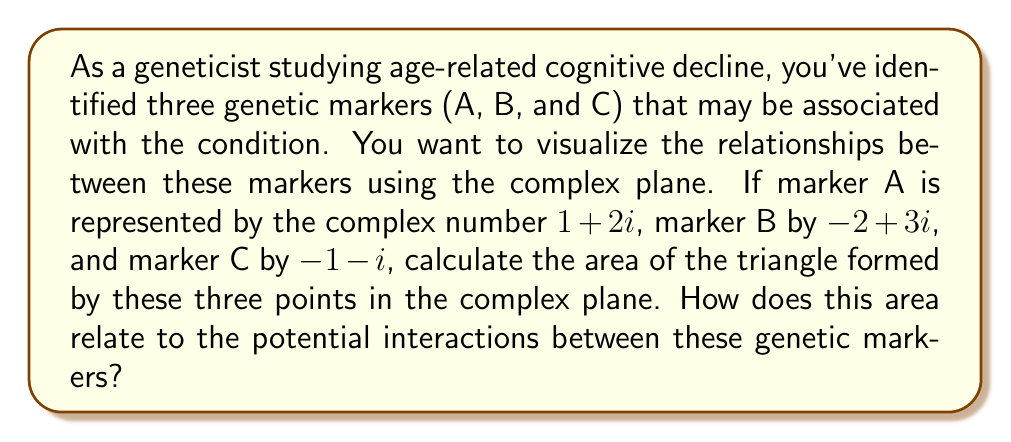Show me your answer to this math problem. To solve this problem, we'll follow these steps:

1) First, let's plot the points on the complex plane:
   A: $1+2i$
   B: $-2+3i$
   C: $-1-i$

2) To find the area of a triangle in the complex plane, we can use the formula:

   $$\text{Area} = \frac{1}{2}|\text{Im}(z_1\bar{z_2} + z_2\bar{z_3} + z_3\bar{z_1})|$$

   where $z_1$, $z_2$, and $z_3$ are the complex numbers representing the vertices, and $\bar{z}$ denotes the complex conjugate.

3) Let's calculate each term:

   $z_1\bar{z_2} = (1+2i)(-2-3i) = -2-3i-4i-6i^2 = -2-7i+6 = 4-7i$
   
   $z_2\bar{z_3} = (-2+3i)(-1+i) = 2-2i-3i-3i^2 = 2-5i+3 = 5-5i$
   
   $z_3\bar{z_1} = (-1-i)(1-2i) = -1+2i+i-2i^2 = -1+3i+2 = 1+3i$

4) Sum these terms:

   $(4-7i) + (5-5i) + (1+3i) = 10-9i$

5) Take the imaginary part:

   $\text{Im}(10-9i) = -9$

6) Calculate the absolute value and divide by 2:

   $\text{Area} = \frac{1}{2}|-9| = \frac{9}{2} = 4.5$

The area of the triangle is 4.5 square units in the complex plane.

In the context of genetic markers, this area could represent the magnitude of potential interactions or relationships between the three markers. A larger area might suggest stronger or more complex interactions, while a smaller area might indicate weaker or simpler relationships. However, the interpretation would depend on how the complex numbers were initially assigned to represent the genetic markers and what aspects of the markers they represent (e.g., expression levels, mutation frequencies, etc.).
Answer: The area of the triangle formed by the three genetic markers in the complex plane is 4.5 square units. 